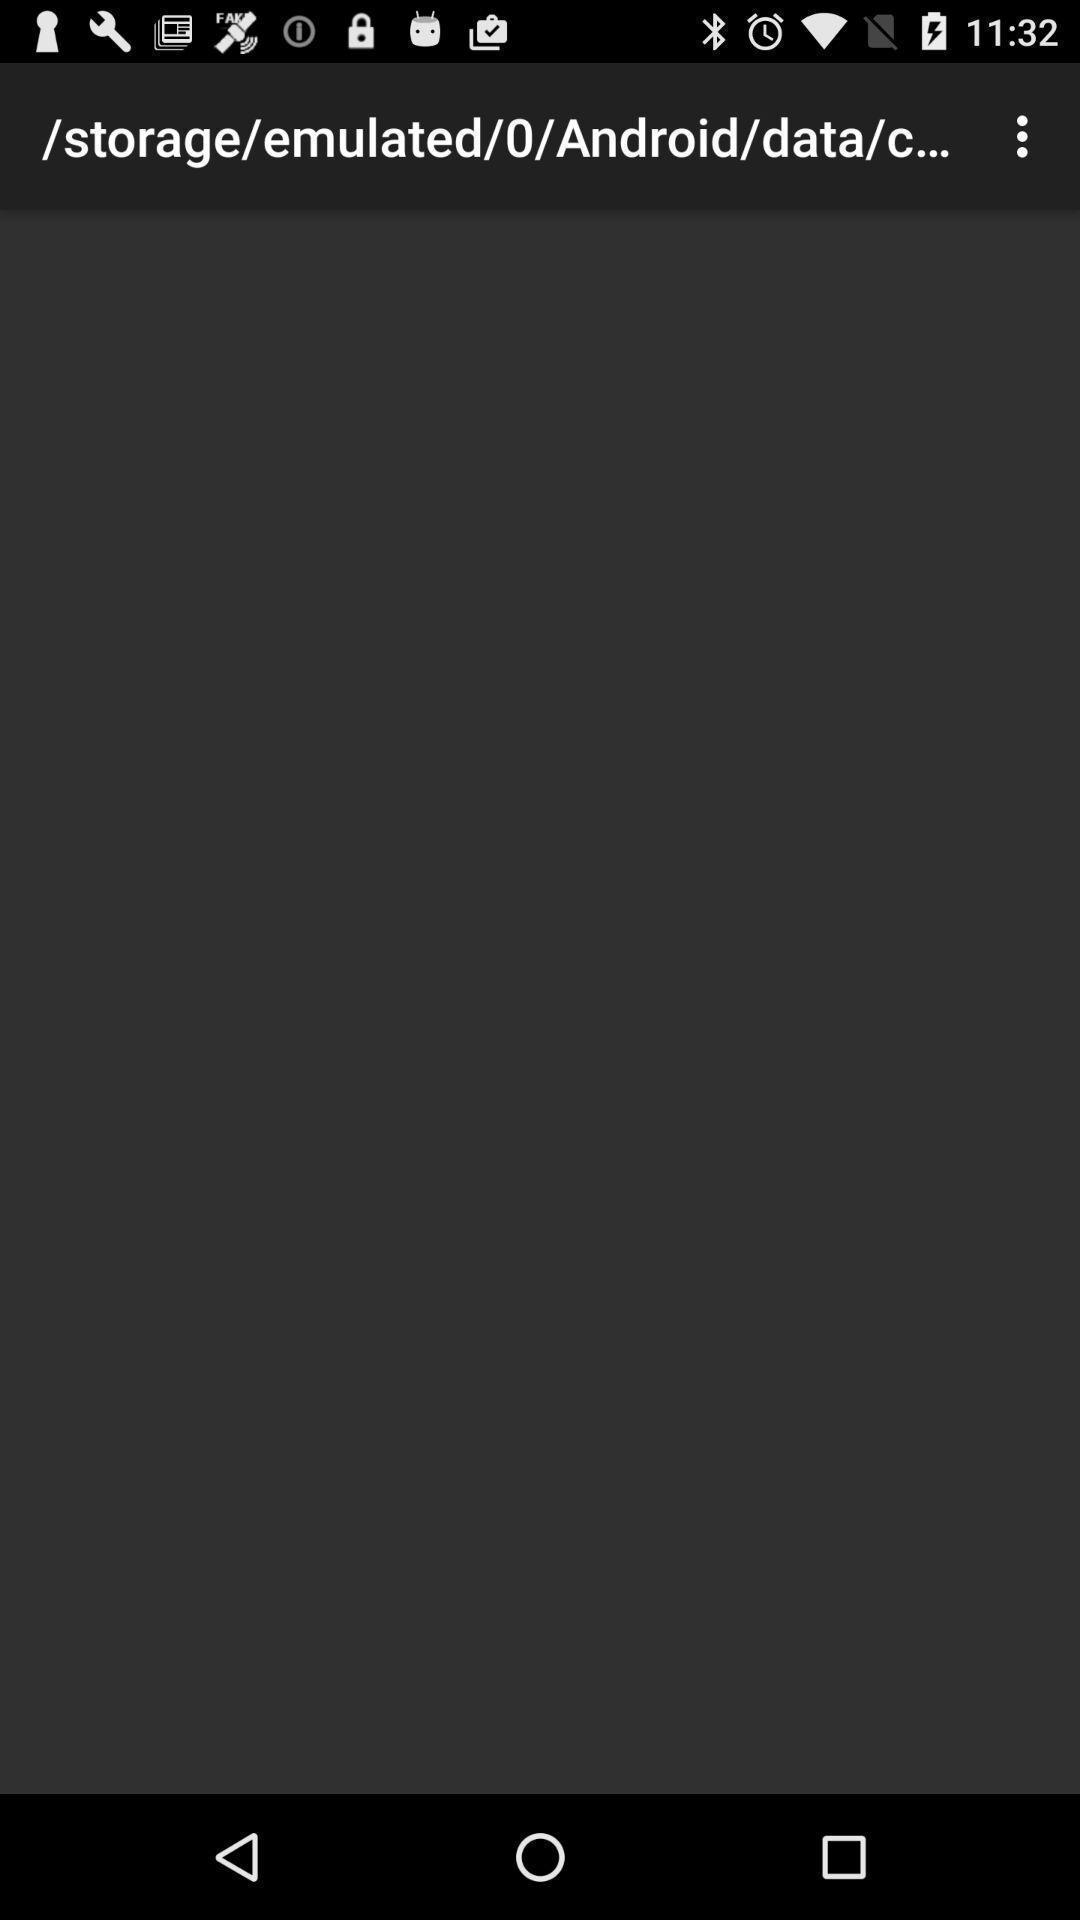Describe the key features of this screenshot. Screen displaying the link page. 